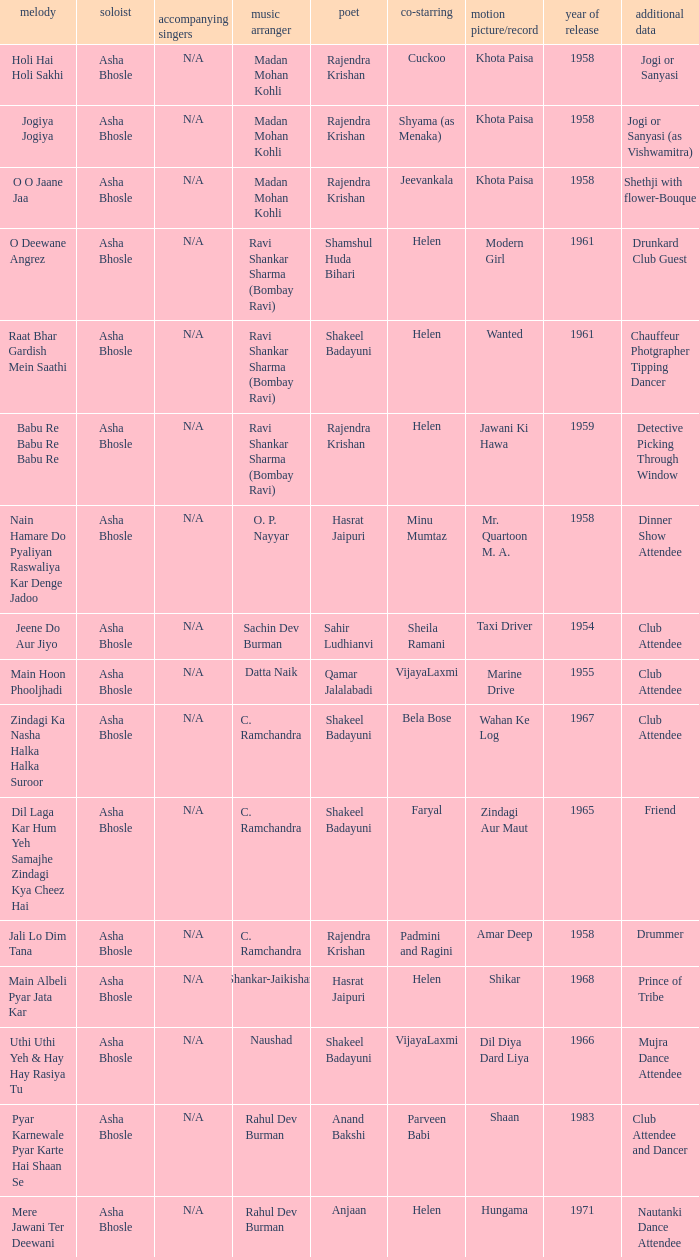What cinematic production had bela bose in a co-starring role? Wahan Ke Log. 